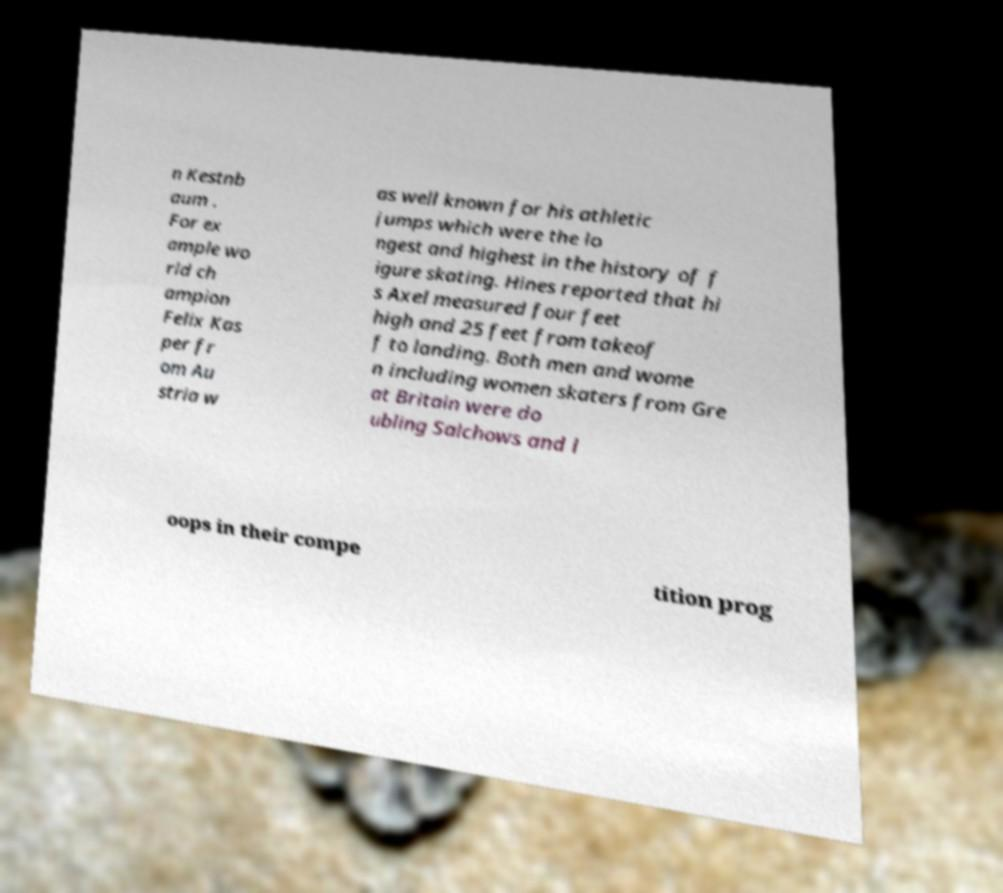Could you extract and type out the text from this image? n Kestnb aum . For ex ample wo rld ch ampion Felix Kas per fr om Au stria w as well known for his athletic jumps which were the lo ngest and highest in the history of f igure skating. Hines reported that hi s Axel measured four feet high and 25 feet from takeof f to landing. Both men and wome n including women skaters from Gre at Britain were do ubling Salchows and l oops in their compe tition prog 